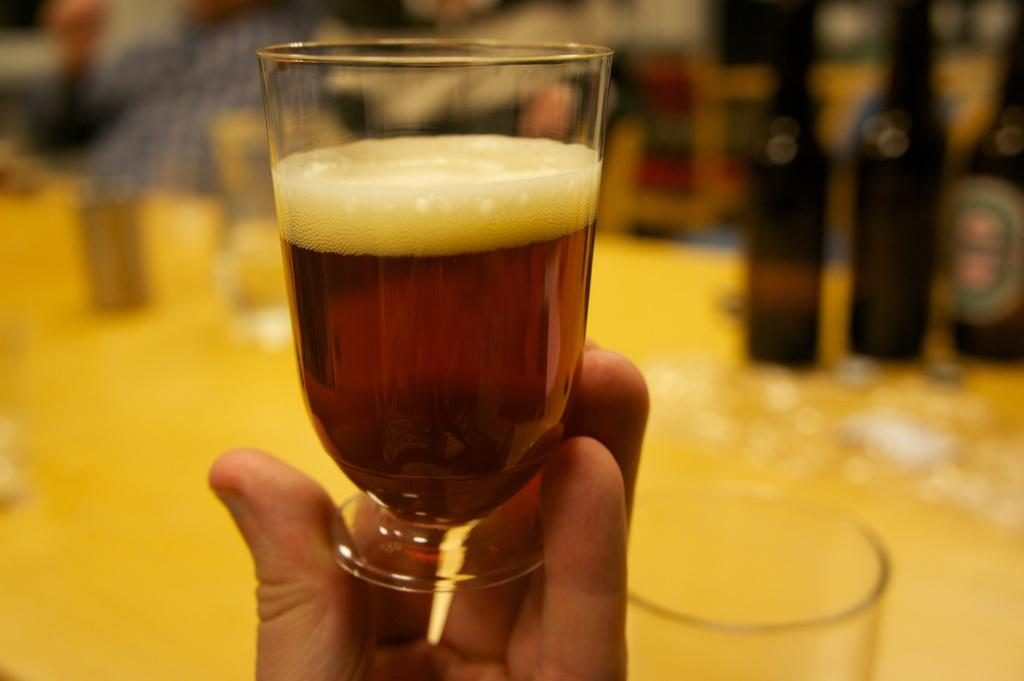What object is being held by a human hand in the image? A wine glass is being held by a human hand in the image. What can be seen on the right side of the image? There are bottles on the right side of the image. What type of bird is sitting on the committee's shoulder in the image? There is no bird or committee present in the image; it only features a human hand holding a wine glass and bottles on the right side. 